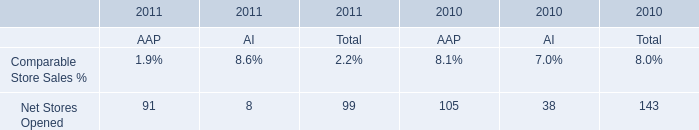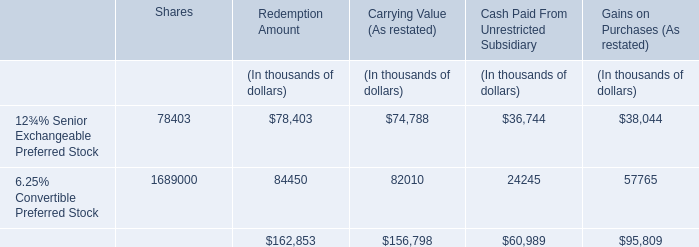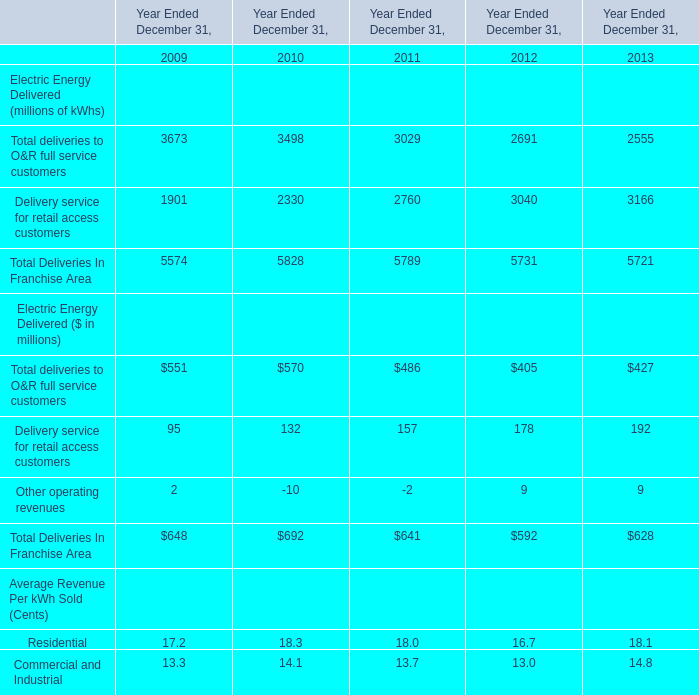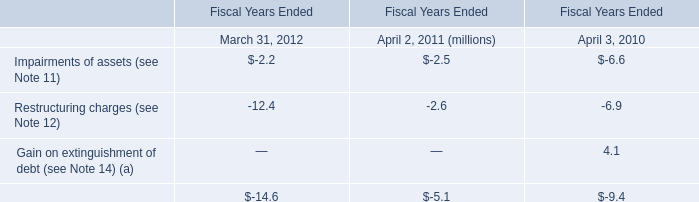What is the sum of Total deliveries to O&R full service customers, Delivery service for retail access customers and Other operating revenues in 2009? (in million) 
Computations: ((551 + 95) + 2)
Answer: 648.0. 